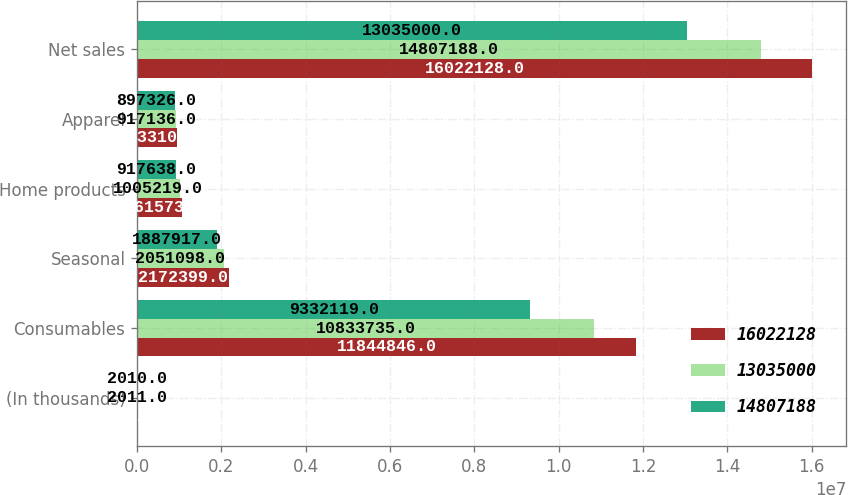<chart> <loc_0><loc_0><loc_500><loc_500><stacked_bar_chart><ecel><fcel>(In thousands)<fcel>Consumables<fcel>Seasonal<fcel>Home products<fcel>Apparel<fcel>Net sales<nl><fcel>1.60221e+07<fcel>2012<fcel>1.18448e+07<fcel>2.1724e+06<fcel>1.06157e+06<fcel>943310<fcel>1.60221e+07<nl><fcel>1.3035e+07<fcel>2011<fcel>1.08337e+07<fcel>2.0511e+06<fcel>1.00522e+06<fcel>917136<fcel>1.48072e+07<nl><fcel>1.48072e+07<fcel>2010<fcel>9.33212e+06<fcel>1.88792e+06<fcel>917638<fcel>897326<fcel>1.3035e+07<nl></chart> 